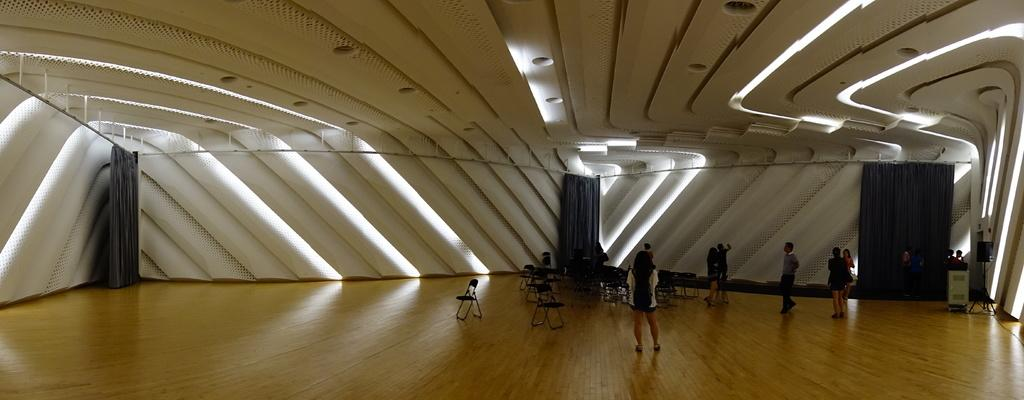What are the people in the image doing? The people in the image are on the floor. What color are the curtains in the image? The curtains in the image are black. What can be seen in the background of the image? There is a wall in the background of the image. What type of wing is visible on the goat in the image? There is no goat or wing present in the image. 